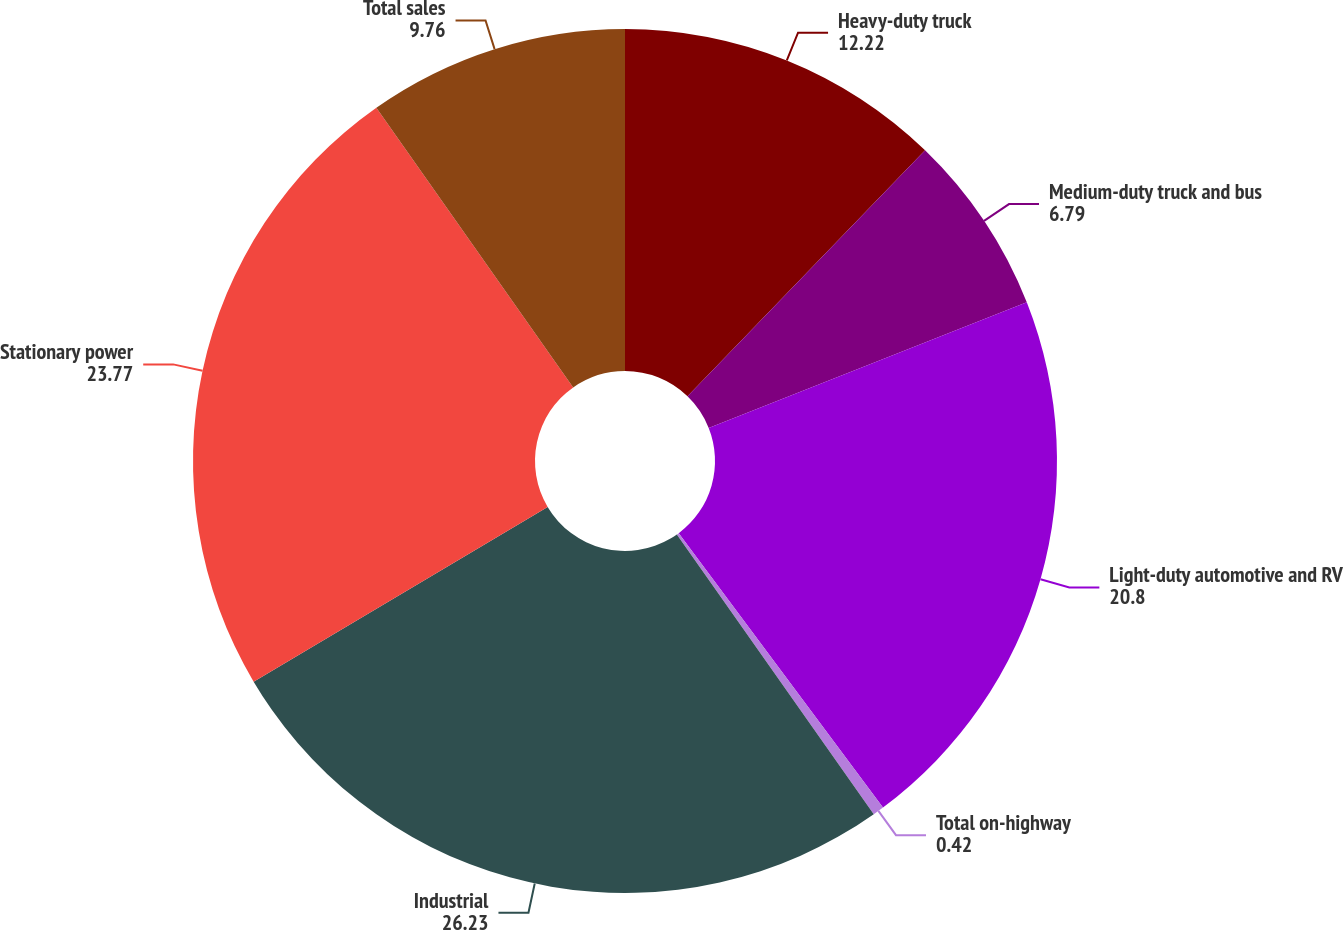<chart> <loc_0><loc_0><loc_500><loc_500><pie_chart><fcel>Heavy-duty truck<fcel>Medium-duty truck and bus<fcel>Light-duty automotive and RV<fcel>Total on-highway<fcel>Industrial<fcel>Stationary power<fcel>Total sales<nl><fcel>12.22%<fcel>6.79%<fcel>20.8%<fcel>0.42%<fcel>26.23%<fcel>23.77%<fcel>9.76%<nl></chart> 